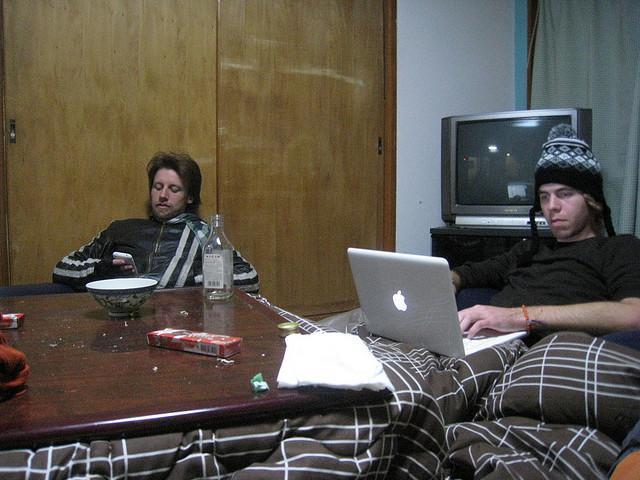How many people are facing the camera?
Give a very brief answer. 2. How many dining tables are there?
Give a very brief answer. 1. How many people are there?
Give a very brief answer. 2. 